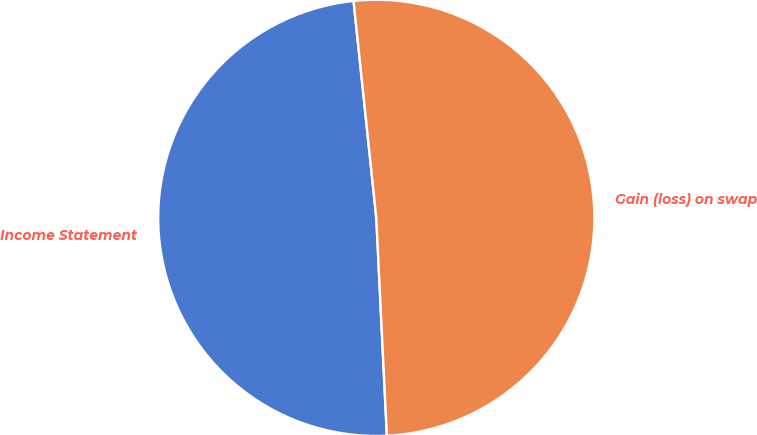<chart> <loc_0><loc_0><loc_500><loc_500><pie_chart><fcel>Income Statement<fcel>Gain (loss) on swap<nl><fcel>49.11%<fcel>50.89%<nl></chart> 